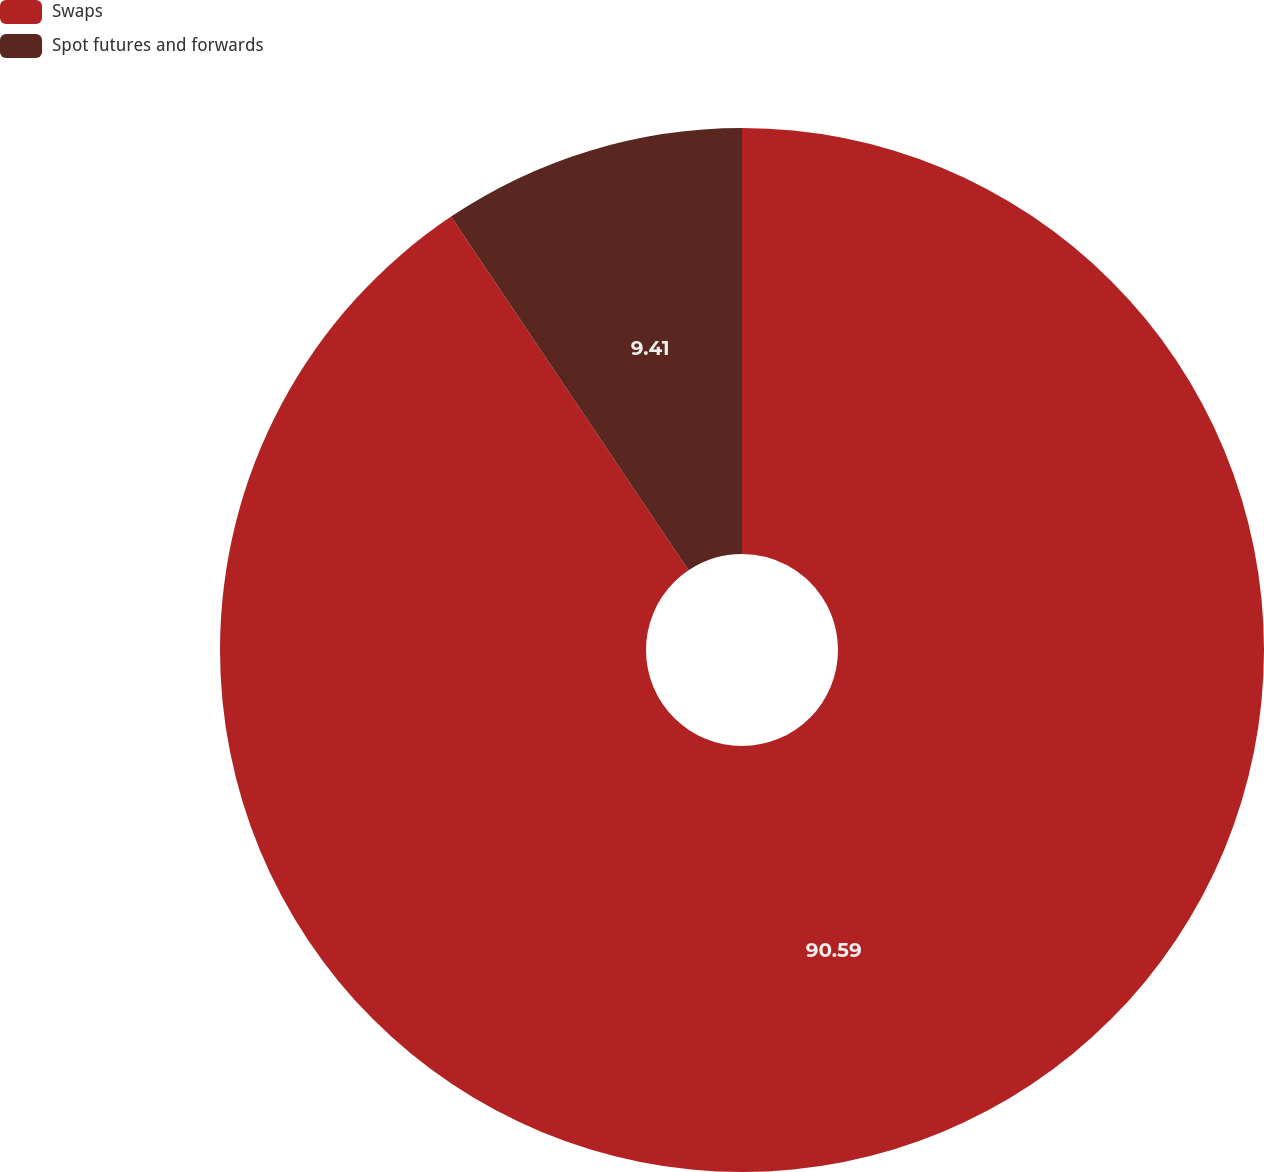Convert chart to OTSL. <chart><loc_0><loc_0><loc_500><loc_500><pie_chart><fcel>Swaps<fcel>Spot futures and forwards<nl><fcel>90.59%<fcel>9.41%<nl></chart> 